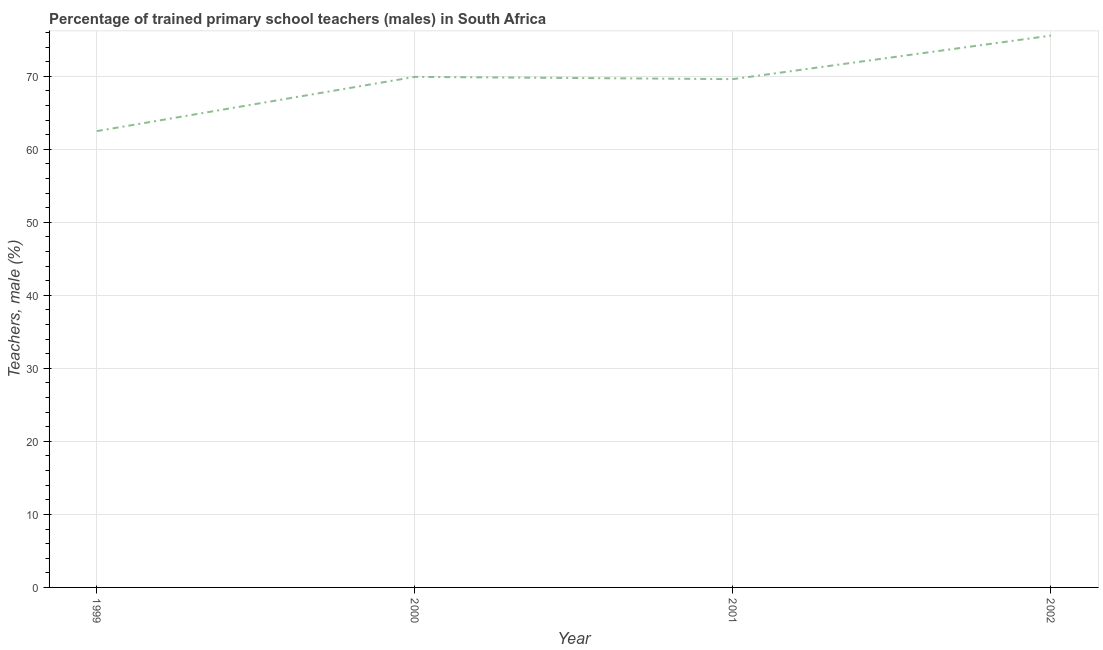What is the percentage of trained male teachers in 2002?
Make the answer very short. 75.57. Across all years, what is the maximum percentage of trained male teachers?
Give a very brief answer. 75.57. Across all years, what is the minimum percentage of trained male teachers?
Your answer should be compact. 62.49. In which year was the percentage of trained male teachers maximum?
Provide a short and direct response. 2002. What is the sum of the percentage of trained male teachers?
Provide a succinct answer. 277.59. What is the difference between the percentage of trained male teachers in 2001 and 2002?
Ensure brevity in your answer.  -5.96. What is the average percentage of trained male teachers per year?
Your answer should be very brief. 69.4. What is the median percentage of trained male teachers?
Ensure brevity in your answer.  69.76. Do a majority of the years between 2001 and 2000 (inclusive) have percentage of trained male teachers greater than 66 %?
Your response must be concise. No. What is the ratio of the percentage of trained male teachers in 2000 to that in 2002?
Keep it short and to the point. 0.93. What is the difference between the highest and the second highest percentage of trained male teachers?
Provide a short and direct response. 5.65. Is the sum of the percentage of trained male teachers in 2000 and 2001 greater than the maximum percentage of trained male teachers across all years?
Ensure brevity in your answer.  Yes. What is the difference between the highest and the lowest percentage of trained male teachers?
Offer a very short reply. 13.08. How many lines are there?
Your answer should be very brief. 1. How many years are there in the graph?
Offer a very short reply. 4. Does the graph contain any zero values?
Provide a short and direct response. No. What is the title of the graph?
Give a very brief answer. Percentage of trained primary school teachers (males) in South Africa. What is the label or title of the Y-axis?
Your response must be concise. Teachers, male (%). What is the Teachers, male (%) of 1999?
Your response must be concise. 62.49. What is the Teachers, male (%) of 2000?
Give a very brief answer. 69.92. What is the Teachers, male (%) in 2001?
Offer a very short reply. 69.61. What is the Teachers, male (%) of 2002?
Provide a short and direct response. 75.57. What is the difference between the Teachers, male (%) in 1999 and 2000?
Provide a succinct answer. -7.42. What is the difference between the Teachers, male (%) in 1999 and 2001?
Your answer should be very brief. -7.12. What is the difference between the Teachers, male (%) in 1999 and 2002?
Offer a terse response. -13.08. What is the difference between the Teachers, male (%) in 2000 and 2001?
Offer a terse response. 0.31. What is the difference between the Teachers, male (%) in 2000 and 2002?
Ensure brevity in your answer.  -5.65. What is the difference between the Teachers, male (%) in 2001 and 2002?
Keep it short and to the point. -5.96. What is the ratio of the Teachers, male (%) in 1999 to that in 2000?
Make the answer very short. 0.89. What is the ratio of the Teachers, male (%) in 1999 to that in 2001?
Provide a succinct answer. 0.9. What is the ratio of the Teachers, male (%) in 1999 to that in 2002?
Provide a short and direct response. 0.83. What is the ratio of the Teachers, male (%) in 2000 to that in 2001?
Keep it short and to the point. 1. What is the ratio of the Teachers, male (%) in 2000 to that in 2002?
Make the answer very short. 0.93. What is the ratio of the Teachers, male (%) in 2001 to that in 2002?
Ensure brevity in your answer.  0.92. 